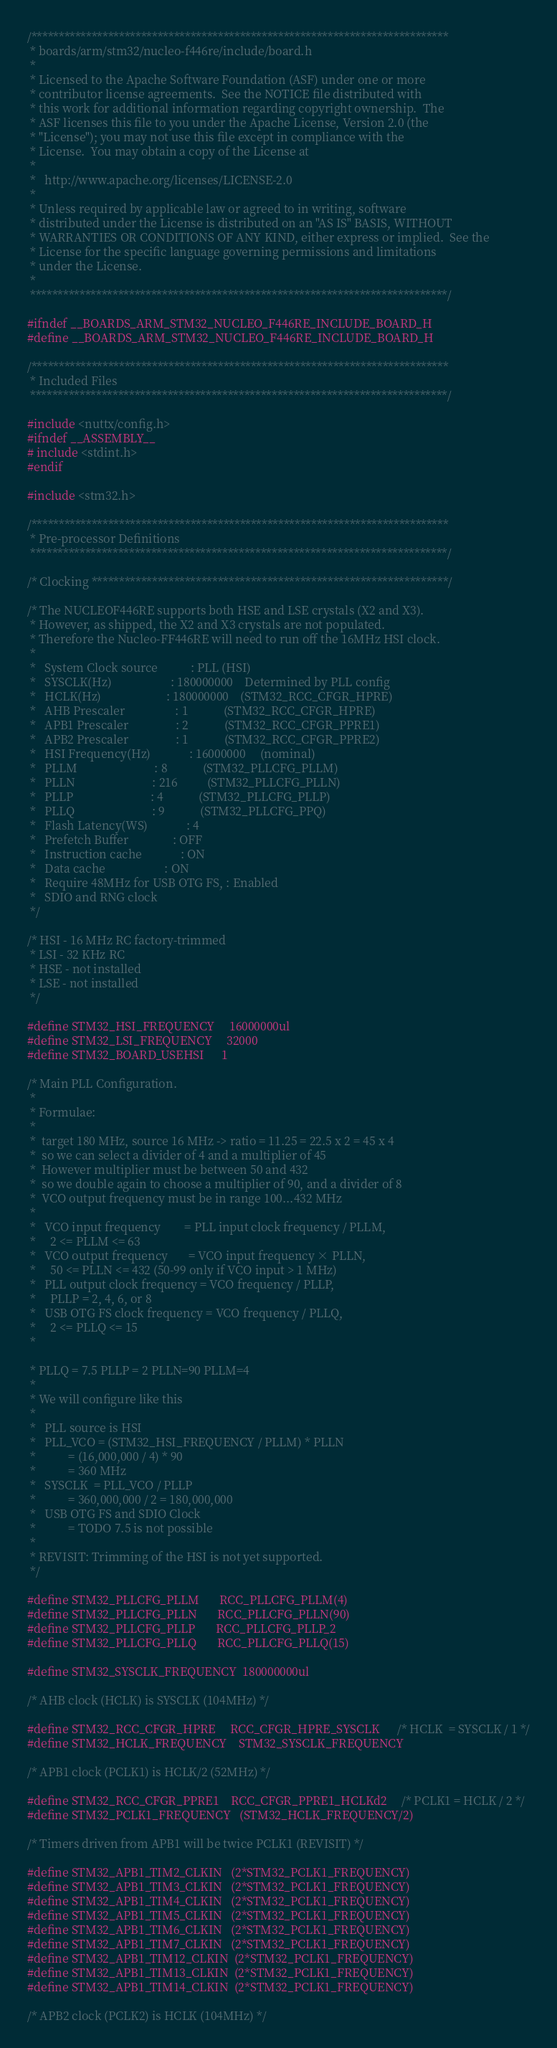<code> <loc_0><loc_0><loc_500><loc_500><_C_>/****************************************************************************
 * boards/arm/stm32/nucleo-f446re/include/board.h
 *
 * Licensed to the Apache Software Foundation (ASF) under one or more
 * contributor license agreements.  See the NOTICE file distributed with
 * this work for additional information regarding copyright ownership.  The
 * ASF licenses this file to you under the Apache License, Version 2.0 (the
 * "License"); you may not use this file except in compliance with the
 * License.  You may obtain a copy of the License at
 *
 *   http://www.apache.org/licenses/LICENSE-2.0
 *
 * Unless required by applicable law or agreed to in writing, software
 * distributed under the License is distributed on an "AS IS" BASIS, WITHOUT
 * WARRANTIES OR CONDITIONS OF ANY KIND, either express or implied.  See the
 * License for the specific language governing permissions and limitations
 * under the License.
 *
 ****************************************************************************/

#ifndef __BOARDS_ARM_STM32_NUCLEO_F446RE_INCLUDE_BOARD_H
#define __BOARDS_ARM_STM32_NUCLEO_F446RE_INCLUDE_BOARD_H

/****************************************************************************
 * Included Files
 ****************************************************************************/

#include <nuttx/config.h>
#ifndef __ASSEMBLY__
# include <stdint.h>
#endif

#include <stm32.h>

/****************************************************************************
 * Pre-processor Definitions
 ****************************************************************************/

/* Clocking *****************************************************************/

/* The NUCLEOF446RE supports both HSE and LSE crystals (X2 and X3).
 * However, as shipped, the X2 and X3 crystals are not populated.
 * Therefore the Nucleo-FF446RE will need to run off the 16MHz HSI clock.
 *
 *   System Clock source           : PLL (HSI)
 *   SYSCLK(Hz)                    : 180000000    Determined by PLL config
 *   HCLK(Hz)                      : 180000000    (STM32_RCC_CFGR_HPRE)
 *   AHB Prescaler                 : 1            (STM32_RCC_CFGR_HPRE)
 *   APB1 Prescaler                : 2            (STM32_RCC_CFGR_PPRE1)
 *   APB2 Prescaler                : 1            (STM32_RCC_CFGR_PPRE2)
 *   HSI Frequency(Hz)             : 16000000     (nominal)
 *   PLLM                          : 8            (STM32_PLLCFG_PLLM)
 *   PLLN                          : 216          (STM32_PLLCFG_PLLN)
 *   PLLP                          : 4            (STM32_PLLCFG_PLLP)
 *   PLLQ                          : 9            (STM32_PLLCFG_PPQ)
 *   Flash Latency(WS)             : 4
 *   Prefetch Buffer               : OFF
 *   Instruction cache             : ON
 *   Data cache                    : ON
 *   Require 48MHz for USB OTG FS, : Enabled
 *   SDIO and RNG clock
 */

/* HSI - 16 MHz RC factory-trimmed
 * LSI - 32 KHz RC
 * HSE - not installed
 * LSE - not installed
 */

#define STM32_HSI_FREQUENCY     16000000ul
#define STM32_LSI_FREQUENCY     32000
#define STM32_BOARD_USEHSI      1

/* Main PLL Configuration.
 *
 * Formulae:
 *
 *  target 180 MHz, source 16 MHz -> ratio = 11.25 = 22.5 x 2 = 45 x 4
 *  so we can select a divider of 4 and a multiplier of 45
 *  However multiplier must be between 50 and 432
 *  so we double again to choose a multiplier of 90, and a divider of 8
 *  VCO output frequency must be in range 100...432 MHz
 *
 *   VCO input frequency        = PLL input clock frequency / PLLM,
 *     2 <= PLLM <= 63
 *   VCO output frequency       = VCO input frequency × PLLN,
 *     50 <= PLLN <= 432 (50-99 only if VCO input > 1 MHz)
 *   PLL output clock frequency = VCO frequency / PLLP,
 *     PLLP = 2, 4, 6, or 8
 *   USB OTG FS clock frequency = VCO frequency / PLLQ,
 *     2 <= PLLQ <= 15
 *

 * PLLQ = 7.5 PLLP = 2 PLLN=90 PLLM=4
 *
 * We will configure like this
 *
 *   PLL source is HSI
 *   PLL_VCO = (STM32_HSI_FREQUENCY / PLLM) * PLLN
 *           = (16,000,000 / 4) * 90
 *           = 360 MHz
 *   SYSCLK  = PLL_VCO / PLLP
 *           = 360,000,000 / 2 = 180,000,000
 *   USB OTG FS and SDIO Clock
 *           = TODO 7.5 is not possible
 *
 * REVISIT: Trimming of the HSI is not yet supported.
 */

#define STM32_PLLCFG_PLLM       RCC_PLLCFG_PLLM(4)
#define STM32_PLLCFG_PLLN       RCC_PLLCFG_PLLN(90)
#define STM32_PLLCFG_PLLP       RCC_PLLCFG_PLLP_2
#define STM32_PLLCFG_PLLQ       RCC_PLLCFG_PLLQ(15)

#define STM32_SYSCLK_FREQUENCY  180000000ul

/* AHB clock (HCLK) is SYSCLK (104MHz) */

#define STM32_RCC_CFGR_HPRE     RCC_CFGR_HPRE_SYSCLK      /* HCLK  = SYSCLK / 1 */
#define STM32_HCLK_FREQUENCY    STM32_SYSCLK_FREQUENCY

/* APB1 clock (PCLK1) is HCLK/2 (52MHz) */

#define STM32_RCC_CFGR_PPRE1    RCC_CFGR_PPRE1_HCLKd2     /* PCLK1 = HCLK / 2 */
#define STM32_PCLK1_FREQUENCY   (STM32_HCLK_FREQUENCY/2)

/* Timers driven from APB1 will be twice PCLK1 (REVISIT) */

#define STM32_APB1_TIM2_CLKIN   (2*STM32_PCLK1_FREQUENCY)
#define STM32_APB1_TIM3_CLKIN   (2*STM32_PCLK1_FREQUENCY)
#define STM32_APB1_TIM4_CLKIN   (2*STM32_PCLK1_FREQUENCY)
#define STM32_APB1_TIM5_CLKIN   (2*STM32_PCLK1_FREQUENCY)
#define STM32_APB1_TIM6_CLKIN   (2*STM32_PCLK1_FREQUENCY)
#define STM32_APB1_TIM7_CLKIN   (2*STM32_PCLK1_FREQUENCY)
#define STM32_APB1_TIM12_CLKIN  (2*STM32_PCLK1_FREQUENCY)
#define STM32_APB1_TIM13_CLKIN  (2*STM32_PCLK1_FREQUENCY)
#define STM32_APB1_TIM14_CLKIN  (2*STM32_PCLK1_FREQUENCY)

/* APB2 clock (PCLK2) is HCLK (104MHz) */
</code> 